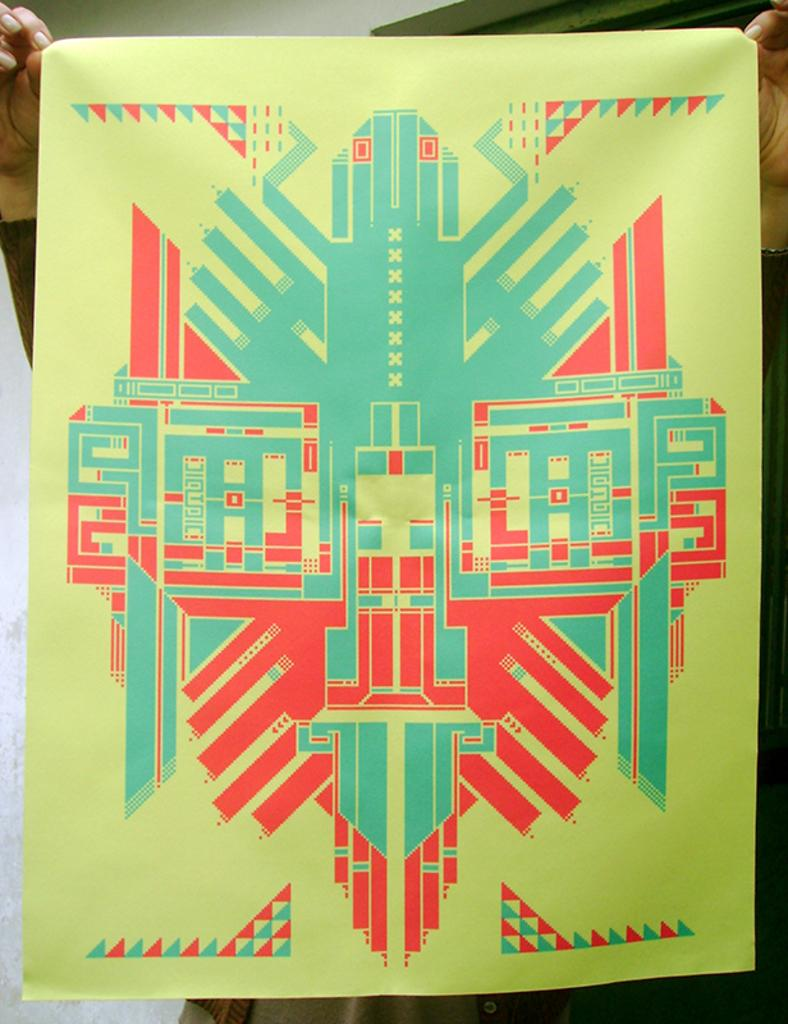What is the main subject in the center of the image? There is a poster in the center of the image. Can you describe any other visible elements in the image? There are hands of a person visible at the top of the image, and there appears to be a wall on the left side of the image. What type of cloth is being used to cover the poster in the image? There is no cloth present in the image; the poster is visible without any covering. 